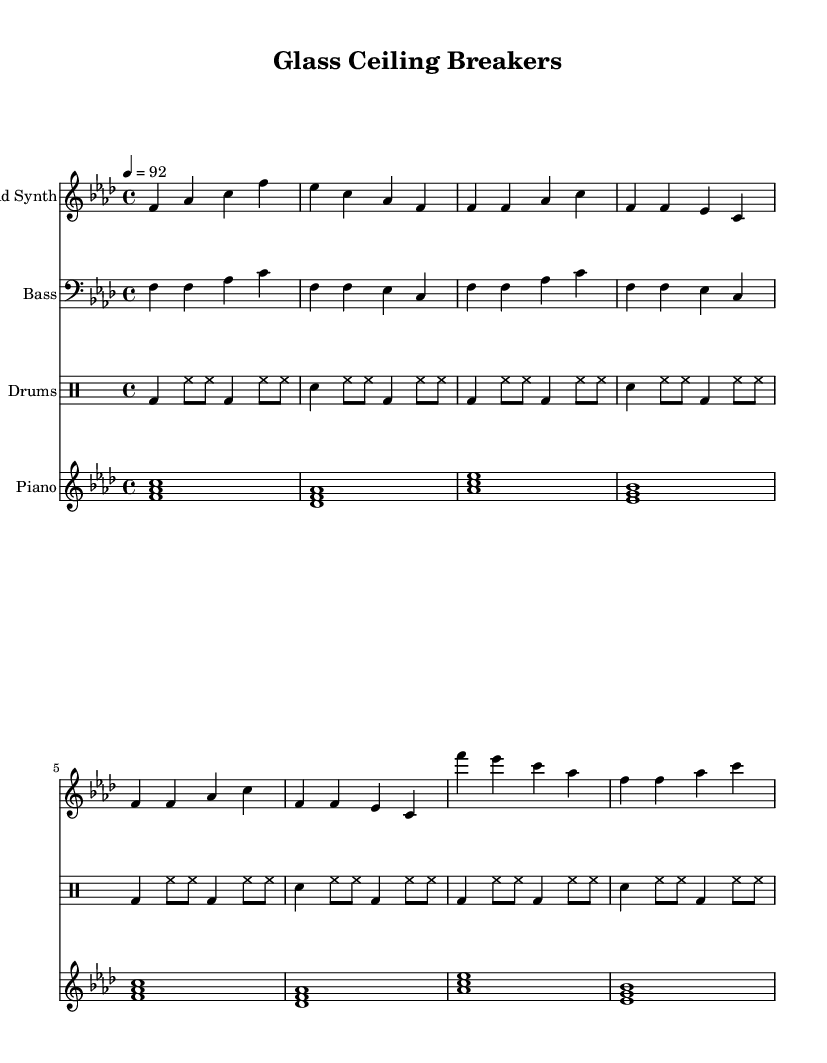What is the key signature of this music? The key signature is indicated by the sharps or flats placed at the beginning of the staff. In this piece, there is one flat (B flat), which shows that it is in F minor.
Answer: F minor What is the time signature of this music? The time signature is indicated at the beginning of the score, represented as a fraction. Here, it is shown as 4/4, meaning there are four beats per measure, and the quarter note gets one beat.
Answer: 4/4 What is the tempo marking in this music? The tempo marking is specified in beats per minute at the beginning, and in this piece, it is marked as "4 = 92," which means there are 92 beats per minute.
Answer: 92 How many measures are in the lead synth part? Counting the measures in the lead synth part, there are a total of 8 measures outlined in the score.
Answer: 8 Which instrument plays the bass line? The bass line is indicated by the clef which is marked as 'Bass.' In this score, the bass part is clearly designated for the bass instrument.
Answer: Bass How do the piano chords change from the first to the last measure? The piano chords move through a series of triads starting from F major, changing to D flat major, then A flat major, and concluding with E flat major, illustrating a progression.
Answer: F, D flat, A flat, E flat What rhythmic pattern do the drums follow? The rhythmic pattern for the drums follows a specific sequence of beats, including bass drum and snare drum hits, and is repeated across four measures, showing a consistent hip-hop groove.
Answer: Sixteenth notes 